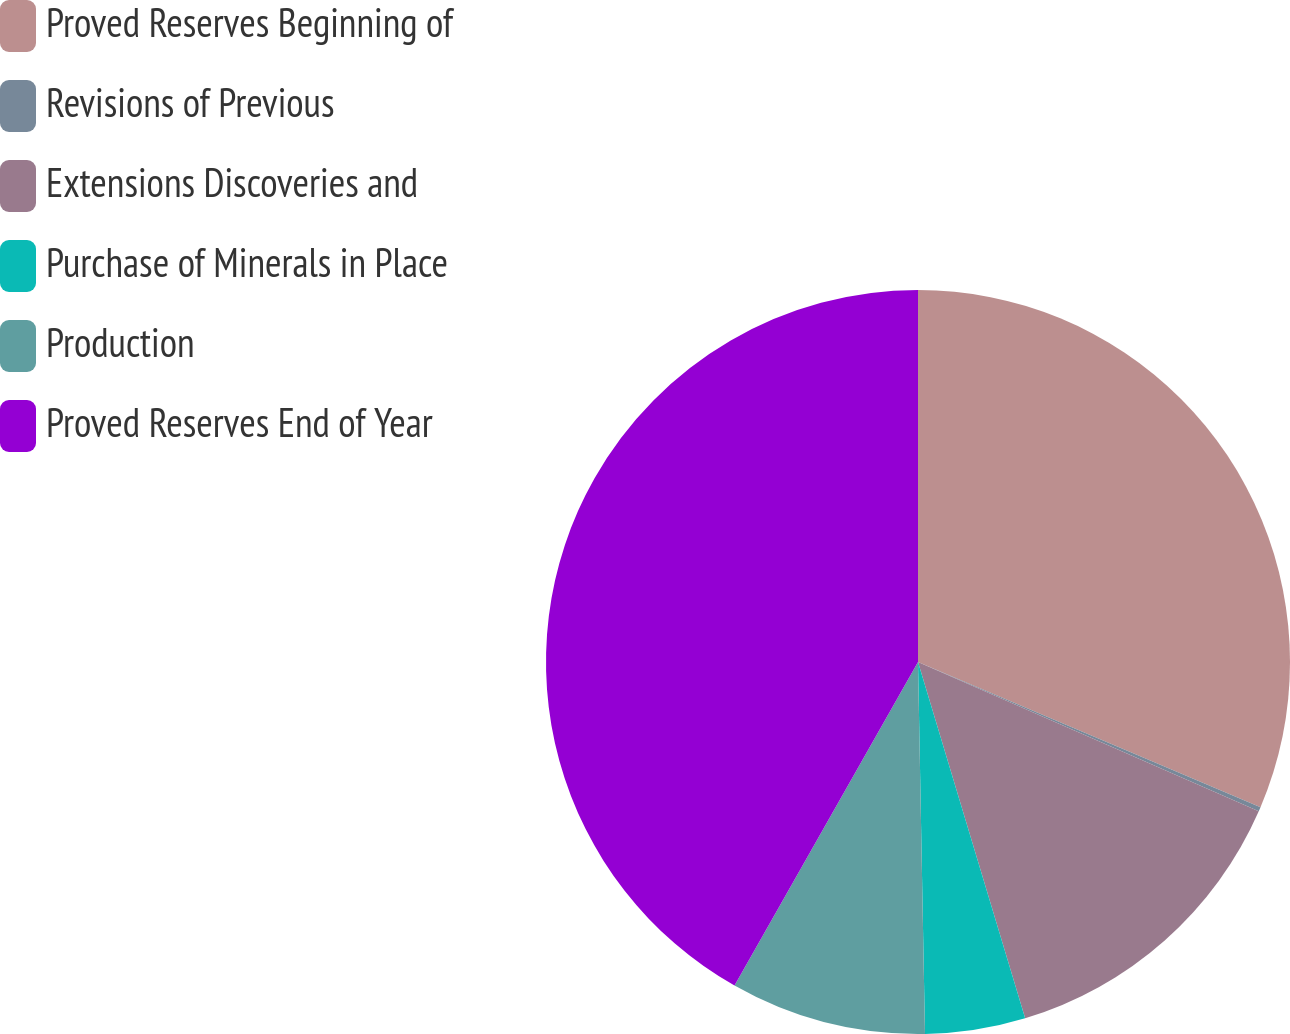Convert chart to OTSL. <chart><loc_0><loc_0><loc_500><loc_500><pie_chart><fcel>Proved Reserves Beginning of<fcel>Revisions of Previous<fcel>Extensions Discoveries and<fcel>Purchase of Minerals in Place<fcel>Production<fcel>Proved Reserves End of Year<nl><fcel>31.38%<fcel>0.19%<fcel>13.78%<fcel>4.35%<fcel>8.51%<fcel>41.79%<nl></chart> 